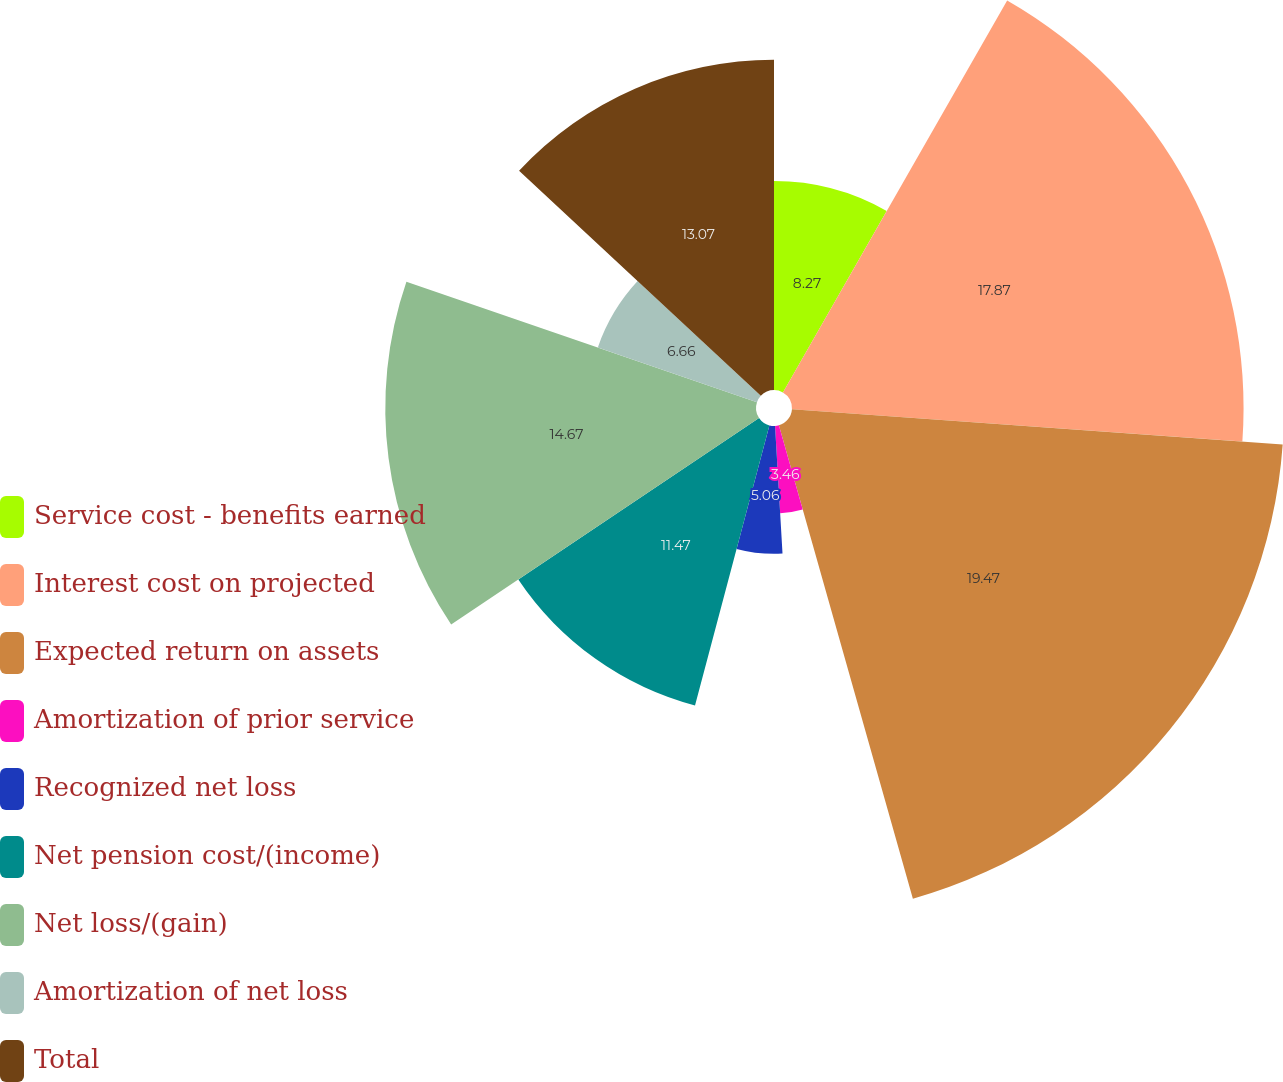Convert chart to OTSL. <chart><loc_0><loc_0><loc_500><loc_500><pie_chart><fcel>Service cost - benefits earned<fcel>Interest cost on projected<fcel>Expected return on assets<fcel>Amortization of prior service<fcel>Recognized net loss<fcel>Net pension cost/(income)<fcel>Net loss/(gain)<fcel>Amortization of net loss<fcel>Total<nl><fcel>8.27%<fcel>17.87%<fcel>19.47%<fcel>3.46%<fcel>5.06%<fcel>11.47%<fcel>14.67%<fcel>6.66%<fcel>13.07%<nl></chart> 